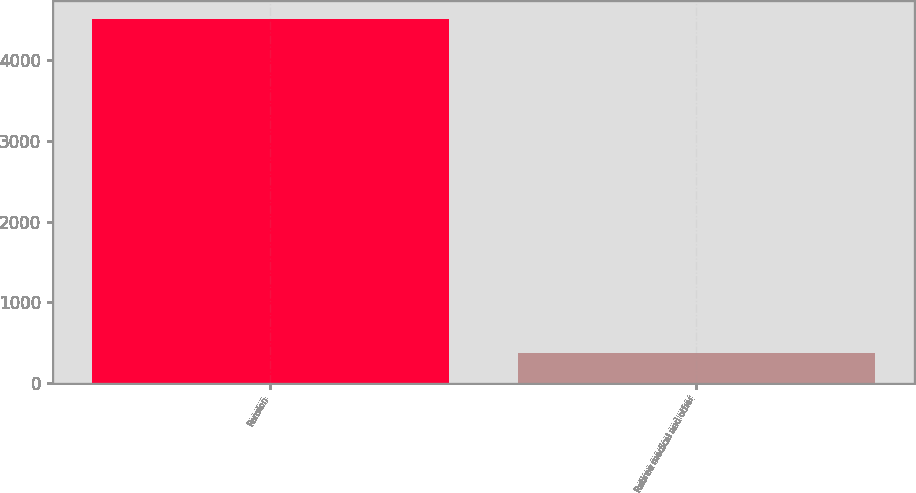<chart> <loc_0><loc_0><loc_500><loc_500><bar_chart><fcel>Pension<fcel>Retiree medical and other<nl><fcel>4515<fcel>374<nl></chart> 